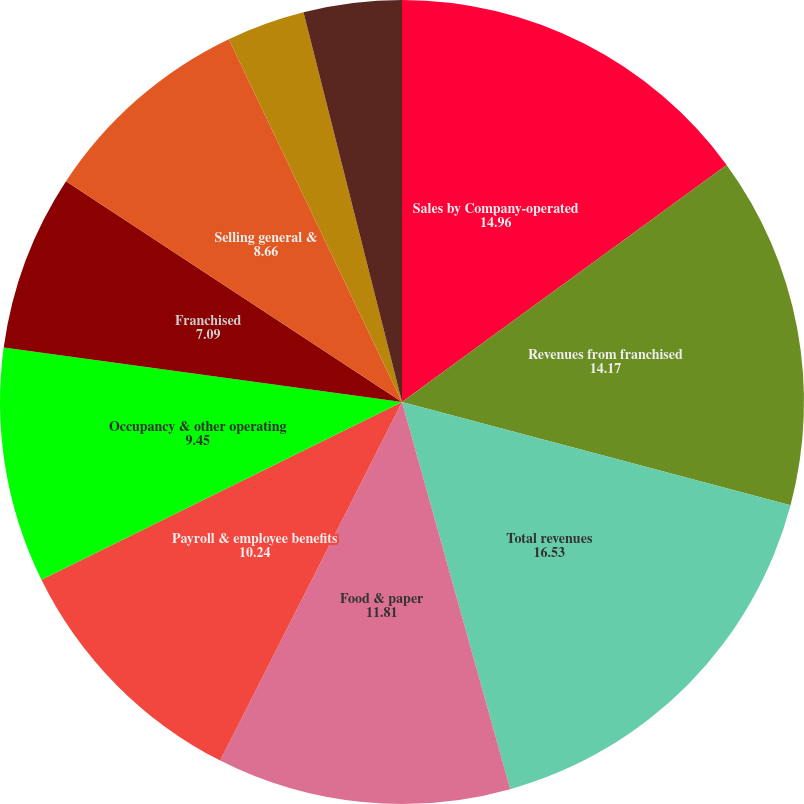Convert chart. <chart><loc_0><loc_0><loc_500><loc_500><pie_chart><fcel>Sales by Company-operated<fcel>Revenues from franchised<fcel>Total revenues<fcel>Food & paper<fcel>Payroll & employee benefits<fcel>Occupancy & other operating<fcel>Franchised<fcel>Selling general &<fcel>Impairment and other charges<fcel>Other operating (income)<nl><fcel>14.96%<fcel>14.17%<fcel>16.53%<fcel>11.81%<fcel>10.24%<fcel>9.45%<fcel>7.09%<fcel>8.66%<fcel>3.15%<fcel>3.94%<nl></chart> 